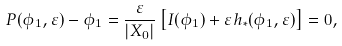<formula> <loc_0><loc_0><loc_500><loc_500>P ( \phi _ { 1 } , \varepsilon ) - \phi _ { 1 } = \frac { \varepsilon } { \left | X _ { 0 } \right | } \left [ I ( \phi _ { 1 } ) + \varepsilon h _ { * } ( \phi _ { 1 } , \varepsilon ) \right ] = 0 ,</formula> 